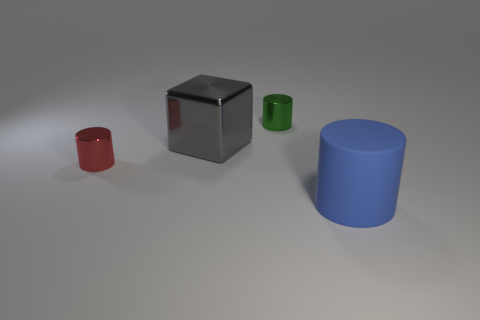Subtract all red shiny cylinders. How many cylinders are left? 2 Add 3 big blue cylinders. How many objects exist? 7 Subtract all blocks. How many objects are left? 3 Add 4 yellow shiny cylinders. How many yellow shiny cylinders exist? 4 Subtract 1 blue cylinders. How many objects are left? 3 Subtract all gray cylinders. Subtract all brown spheres. How many cylinders are left? 3 Subtract all big gray cubes. Subtract all big cyan rubber spheres. How many objects are left? 3 Add 1 tiny red shiny cylinders. How many tiny red shiny cylinders are left? 2 